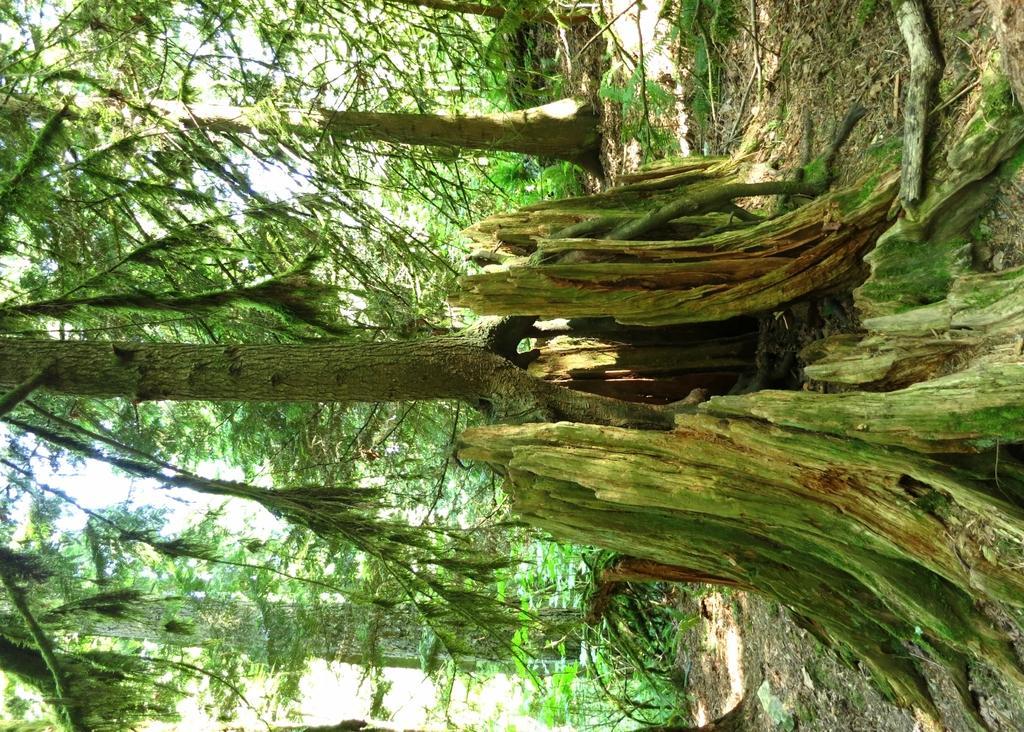Could you give a brief overview of what you see in this image? In this image I can see number of trees. 